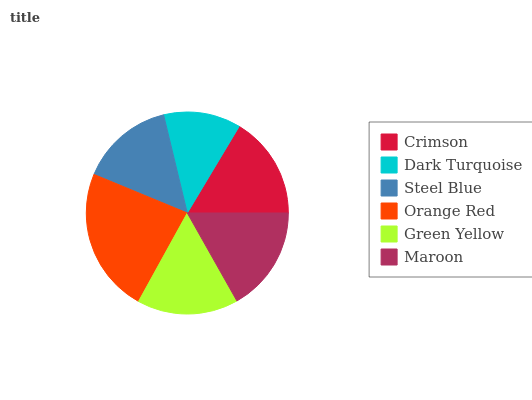Is Dark Turquoise the minimum?
Answer yes or no. Yes. Is Orange Red the maximum?
Answer yes or no. Yes. Is Steel Blue the minimum?
Answer yes or no. No. Is Steel Blue the maximum?
Answer yes or no. No. Is Steel Blue greater than Dark Turquoise?
Answer yes or no. Yes. Is Dark Turquoise less than Steel Blue?
Answer yes or no. Yes. Is Dark Turquoise greater than Steel Blue?
Answer yes or no. No. Is Steel Blue less than Dark Turquoise?
Answer yes or no. No. Is Crimson the high median?
Answer yes or no. Yes. Is Green Yellow the low median?
Answer yes or no. Yes. Is Green Yellow the high median?
Answer yes or no. No. Is Maroon the low median?
Answer yes or no. No. 